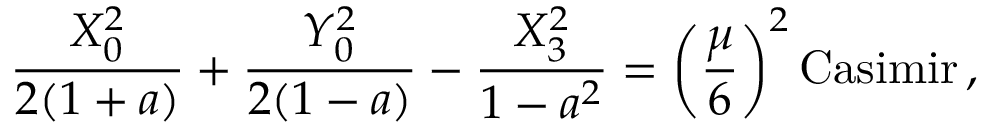<formula> <loc_0><loc_0><loc_500><loc_500>{ \frac { X _ { 0 } ^ { 2 } } { 2 ( 1 + a ) } } + { \frac { Y _ { 0 } ^ { 2 } } { 2 ( 1 - a ) } } - { \frac { X _ { 3 } ^ { 2 } } { 1 - a ^ { 2 } } } = \left ( { \frac { \mu } { 6 } } \right ) ^ { 2 } C a s i m i r \, ,</formula> 